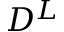Convert formula to latex. <formula><loc_0><loc_0><loc_500><loc_500>D ^ { L }</formula> 